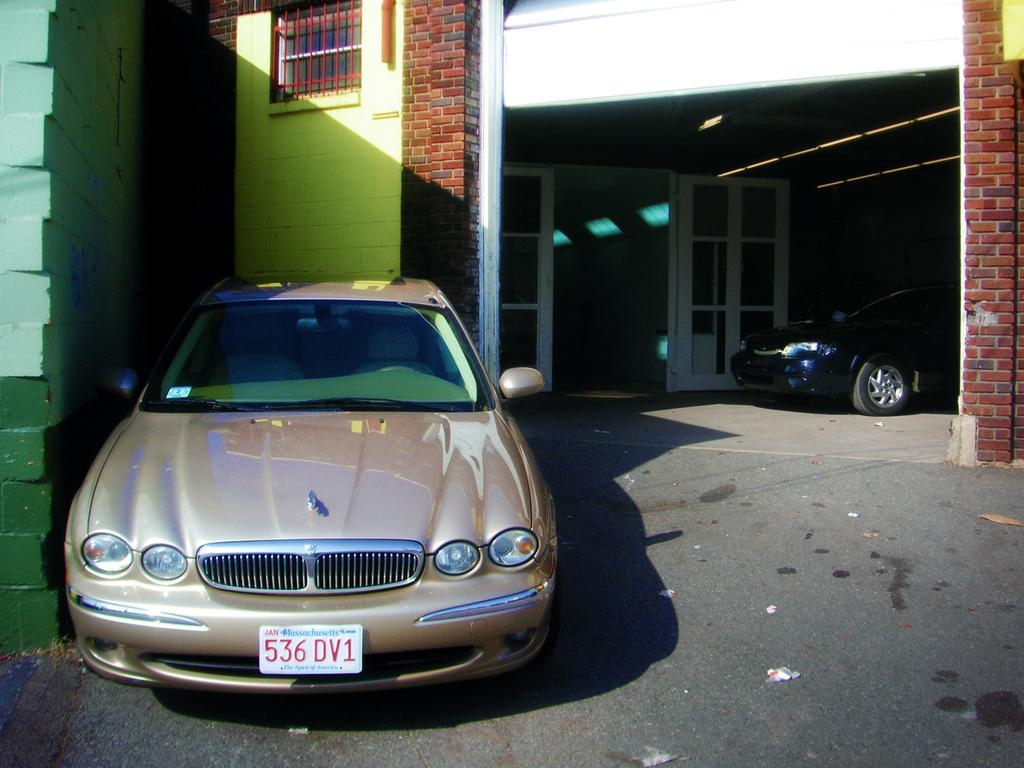How many cars are visible in the image? There are two cars in the image. What is the status of the cars in the image? The cars are parked. What type of structure is present in the image? There is a building in the image. What architectural features can be seen in the image? There is a window and a glass door in the image. What is the texture of the wall in the image? The wall has a brick texture. What type of seed is growing on the roof of the building in the image? There is no seed or plant visible on the roof of the building in the image. 